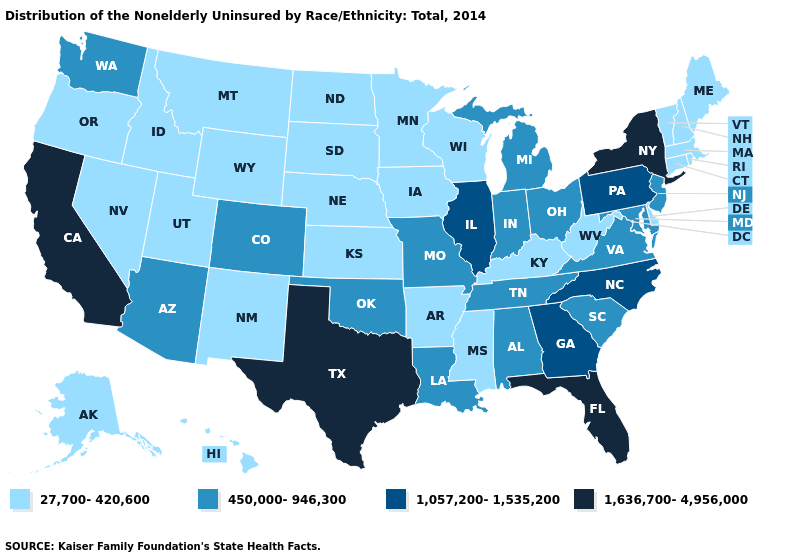Does the first symbol in the legend represent the smallest category?
Give a very brief answer. Yes. Does Virginia have the highest value in the USA?
Write a very short answer. No. What is the value of North Dakota?
Keep it brief. 27,700-420,600. What is the value of Florida?
Concise answer only. 1,636,700-4,956,000. What is the value of Colorado?
Be succinct. 450,000-946,300. Does New York have the lowest value in the USA?
Be succinct. No. Does California have the highest value in the USA?
Be succinct. Yes. How many symbols are there in the legend?
Give a very brief answer. 4. Name the states that have a value in the range 27,700-420,600?
Concise answer only. Alaska, Arkansas, Connecticut, Delaware, Hawaii, Idaho, Iowa, Kansas, Kentucky, Maine, Massachusetts, Minnesota, Mississippi, Montana, Nebraska, Nevada, New Hampshire, New Mexico, North Dakota, Oregon, Rhode Island, South Dakota, Utah, Vermont, West Virginia, Wisconsin, Wyoming. Does Connecticut have the same value as Georgia?
Answer briefly. No. Does Wisconsin have the lowest value in the USA?
Quick response, please. Yes. Which states have the lowest value in the USA?
Give a very brief answer. Alaska, Arkansas, Connecticut, Delaware, Hawaii, Idaho, Iowa, Kansas, Kentucky, Maine, Massachusetts, Minnesota, Mississippi, Montana, Nebraska, Nevada, New Hampshire, New Mexico, North Dakota, Oregon, Rhode Island, South Dakota, Utah, Vermont, West Virginia, Wisconsin, Wyoming. Among the states that border Virginia , which have the highest value?
Concise answer only. North Carolina. What is the value of Washington?
Quick response, please. 450,000-946,300. What is the value of New Jersey?
Concise answer only. 450,000-946,300. 